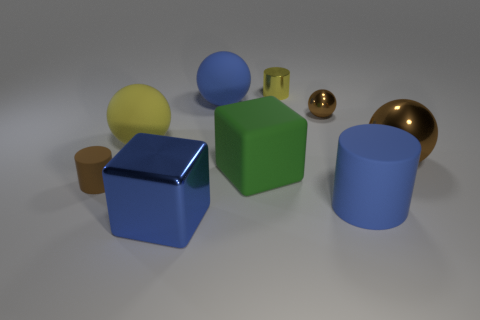What color is the tiny sphere behind the blue matte object that is right of the tiny yellow metal thing?
Your answer should be very brief. Brown. Are there any tiny objects of the same color as the big rubber cube?
Your answer should be very brief. No. What is the color of the metal ball that is the same size as the green matte thing?
Make the answer very short. Brown. Do the small brown object right of the large metal block and the large brown object have the same material?
Ensure brevity in your answer.  Yes. Is there a small brown metallic sphere in front of the small cylinder on the left side of the large metal thing that is to the left of the green cube?
Ensure brevity in your answer.  No. There is a tiny brown object in front of the yellow rubber thing; does it have the same shape as the blue metallic object?
Your response must be concise. No. The large blue thing behind the big blue rubber thing in front of the tiny rubber object is what shape?
Provide a succinct answer. Sphere. What is the size of the blue object behind the rubber thing in front of the small brown thing that is on the left side of the blue block?
Your response must be concise. Large. There is another metal thing that is the same shape as the large brown thing; what color is it?
Ensure brevity in your answer.  Brown. Is the size of the green object the same as the yellow shiny thing?
Keep it short and to the point. No. 